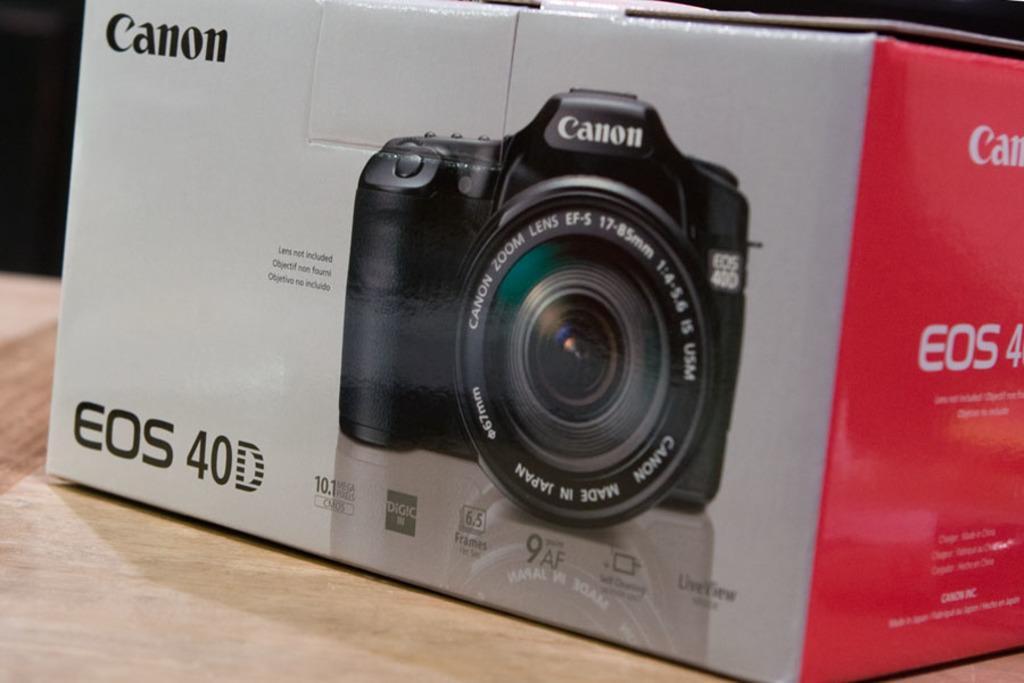Could you give a brief overview of what you see in this image? In this image we can see a box on a surface. On the box there is an image of a camera. Also something is written on the box. 